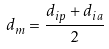Convert formula to latex. <formula><loc_0><loc_0><loc_500><loc_500>d _ { m } = \frac { d _ { i p } + d _ { i a } } { 2 }</formula> 